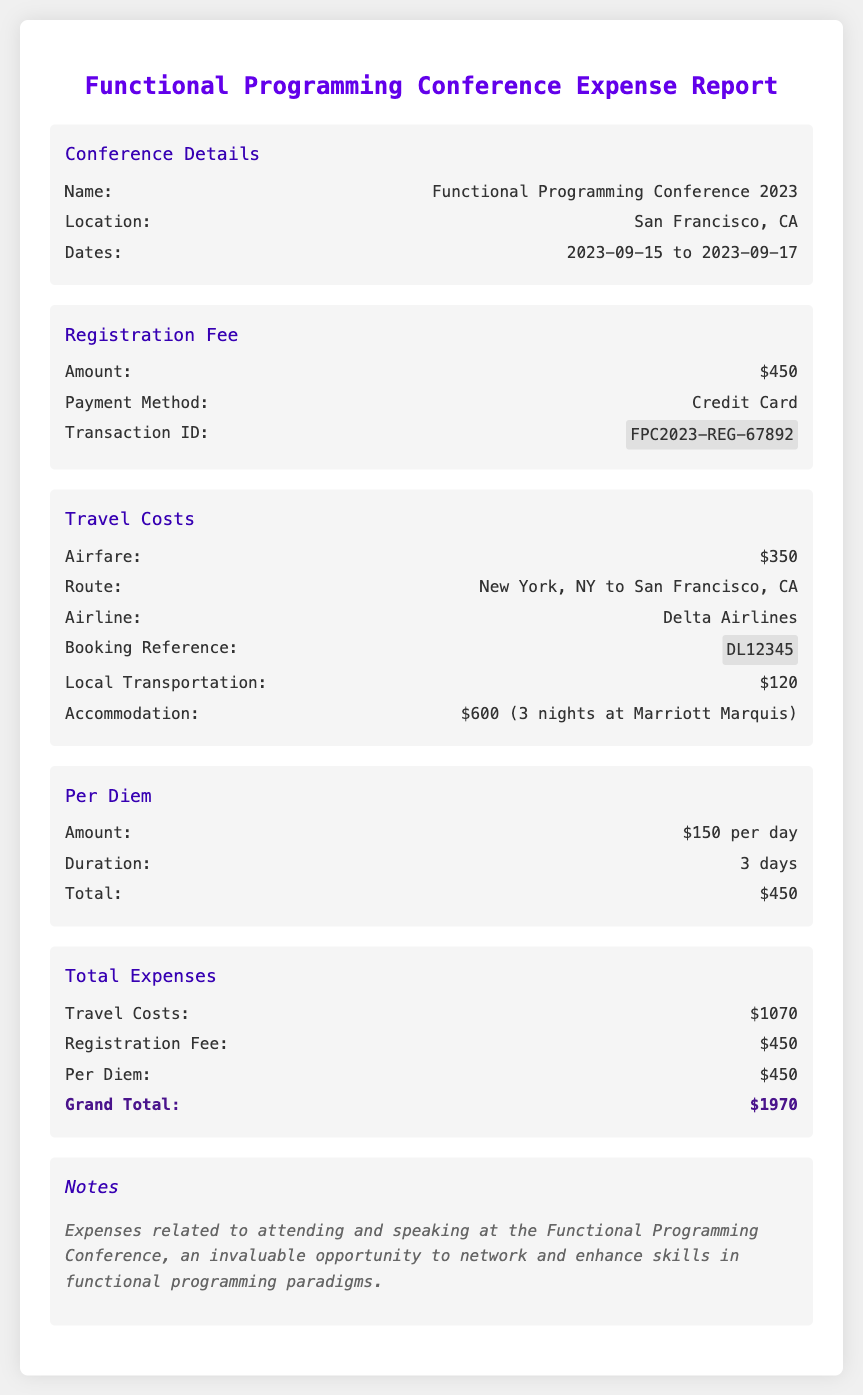What is the location of the conference? The document states that the conference is held in San Francisco, CA.
Answer: San Francisco, CA What is the date range of the conference? The document specifies the dates of the conference are from September 15 to September 17, 2023.
Answer: 2023-09-15 to 2023-09-17 What is the registration fee amount? The document lists the registration fee amount as $450.
Answer: $450 What is the total cost of travel? The total travel costs are provided in the document as $1070.
Answer: $1070 How much is the per diem amount per day? The document indicates that the per diem is $150 per day.
Answer: $150 per day What is the grand total of all expenses? The grand total is mentioned as the sum of all expenses amounting to $1970.
Answer: $1970 Which airline was used for travel? The document specifies Delta Airlines as the airline used for travel.
Answer: Delta Airlines What is the transaction ID for registration? The transaction ID for the registration fee is provided as FPC2023-REG-67892.
Answer: FPC2023-REG-67892 How many nights was accommodation booked for? The accommodation was booked for three nights, as noted in the travel costs.
Answer: 3 nights 